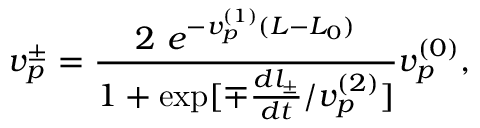<formula> <loc_0><loc_0><loc_500><loc_500>v _ { p } ^ { \pm } = \frac { 2 \ e ^ { - v _ { p } ^ { ( 1 ) } ( L - L _ { 0 } ) } } { 1 + \exp [ \mp \frac { d l _ { \pm } } { d t } / v _ { p } ^ { ( 2 ) } ] } v _ { p } ^ { ( 0 ) } ,</formula> 